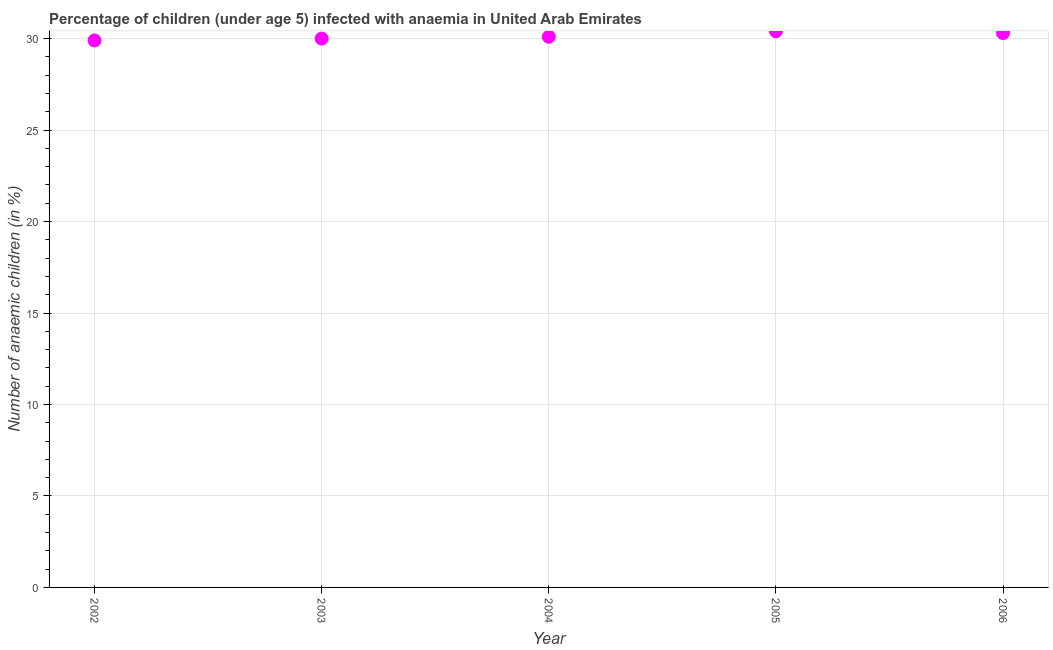What is the number of anaemic children in 2002?
Your answer should be very brief. 29.9. Across all years, what is the maximum number of anaemic children?
Your answer should be very brief. 30.4. Across all years, what is the minimum number of anaemic children?
Ensure brevity in your answer.  29.9. What is the sum of the number of anaemic children?
Give a very brief answer. 150.7. What is the difference between the number of anaemic children in 2003 and 2004?
Keep it short and to the point. -0.1. What is the average number of anaemic children per year?
Make the answer very short. 30.14. What is the median number of anaemic children?
Your answer should be compact. 30.1. In how many years, is the number of anaemic children greater than 9 %?
Give a very brief answer. 5. Do a majority of the years between 2004 and 2006 (inclusive) have number of anaemic children greater than 23 %?
Give a very brief answer. Yes. What is the ratio of the number of anaemic children in 2004 to that in 2006?
Your response must be concise. 0.99. Is the difference between the number of anaemic children in 2003 and 2004 greater than the difference between any two years?
Your response must be concise. No. What is the difference between the highest and the second highest number of anaemic children?
Your answer should be compact. 0.1. In how many years, is the number of anaemic children greater than the average number of anaemic children taken over all years?
Ensure brevity in your answer.  2. Does the number of anaemic children monotonically increase over the years?
Provide a succinct answer. No. How many years are there in the graph?
Your response must be concise. 5. What is the difference between two consecutive major ticks on the Y-axis?
Offer a terse response. 5. Are the values on the major ticks of Y-axis written in scientific E-notation?
Offer a very short reply. No. Does the graph contain any zero values?
Make the answer very short. No. Does the graph contain grids?
Ensure brevity in your answer.  Yes. What is the title of the graph?
Give a very brief answer. Percentage of children (under age 5) infected with anaemia in United Arab Emirates. What is the label or title of the X-axis?
Ensure brevity in your answer.  Year. What is the label or title of the Y-axis?
Provide a short and direct response. Number of anaemic children (in %). What is the Number of anaemic children (in %) in 2002?
Keep it short and to the point. 29.9. What is the Number of anaemic children (in %) in 2003?
Your answer should be very brief. 30. What is the Number of anaemic children (in %) in 2004?
Keep it short and to the point. 30.1. What is the Number of anaemic children (in %) in 2005?
Make the answer very short. 30.4. What is the Number of anaemic children (in %) in 2006?
Your response must be concise. 30.3. What is the difference between the Number of anaemic children (in %) in 2002 and 2003?
Your answer should be compact. -0.1. What is the difference between the Number of anaemic children (in %) in 2002 and 2005?
Ensure brevity in your answer.  -0.5. What is the difference between the Number of anaemic children (in %) in 2003 and 2005?
Keep it short and to the point. -0.4. What is the difference between the Number of anaemic children (in %) in 2003 and 2006?
Provide a succinct answer. -0.3. What is the difference between the Number of anaemic children (in %) in 2004 and 2006?
Keep it short and to the point. -0.2. What is the ratio of the Number of anaemic children (in %) in 2002 to that in 2003?
Your response must be concise. 1. What is the ratio of the Number of anaemic children (in %) in 2002 to that in 2006?
Offer a very short reply. 0.99. What is the ratio of the Number of anaemic children (in %) in 2003 to that in 2006?
Your response must be concise. 0.99. What is the ratio of the Number of anaemic children (in %) in 2004 to that in 2006?
Your answer should be compact. 0.99. 